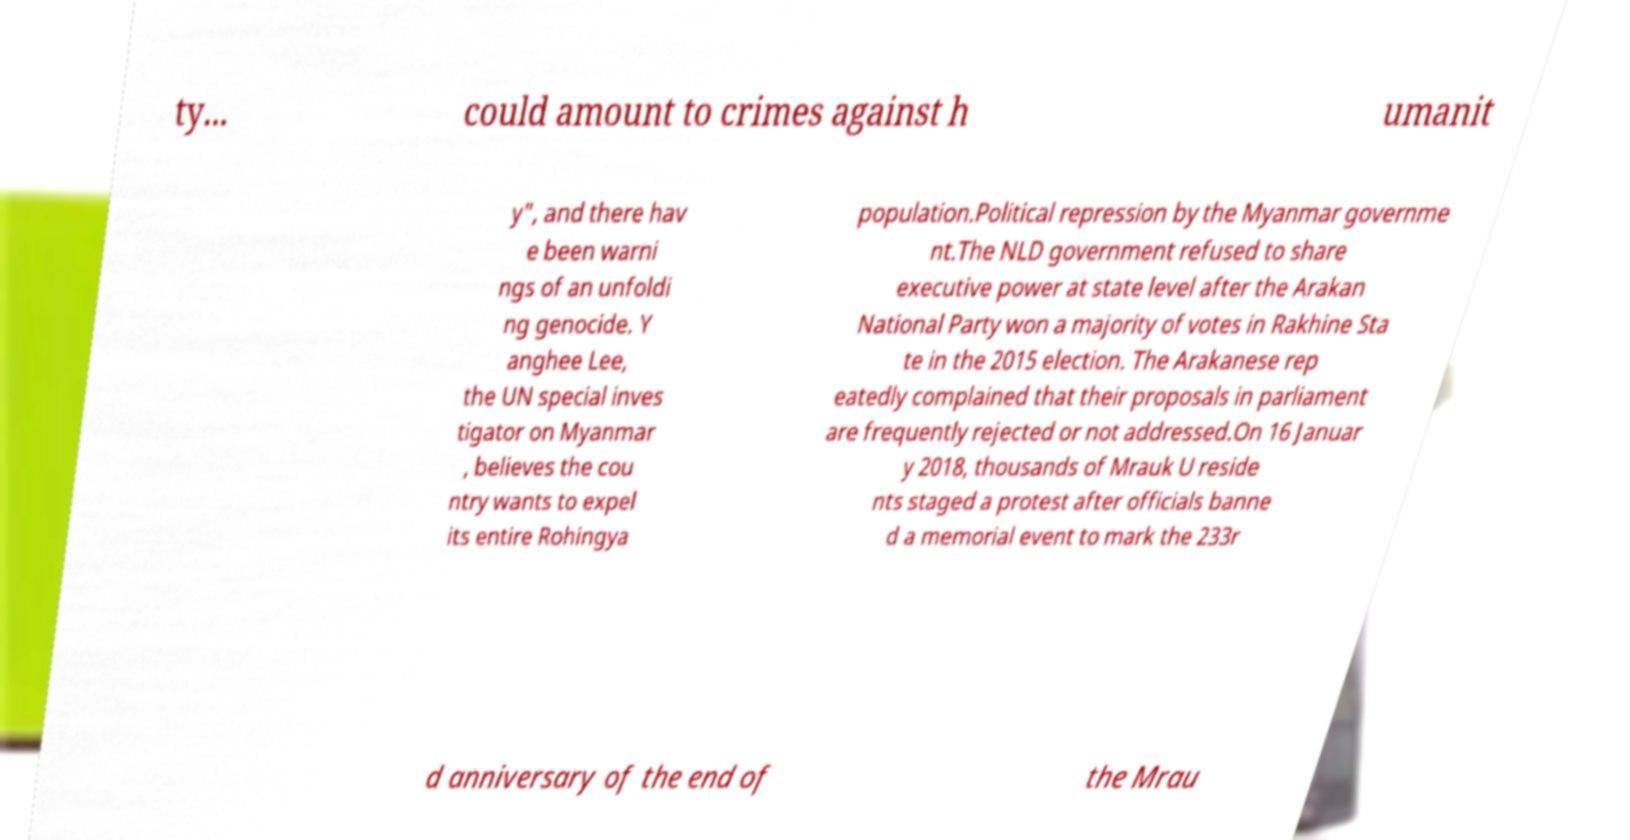Please read and relay the text visible in this image. What does it say? ty... could amount to crimes against h umanit y", and there hav e been warni ngs of an unfoldi ng genocide. Y anghee Lee, the UN special inves tigator on Myanmar , believes the cou ntry wants to expel its entire Rohingya population.Political repression by the Myanmar governme nt.The NLD government refused to share executive power at state level after the Arakan National Party won a majority of votes in Rakhine Sta te in the 2015 election. The Arakanese rep eatedly complained that their proposals in parliament are frequently rejected or not addressed.On 16 Januar y 2018, thousands of Mrauk U reside nts staged a protest after officials banne d a memorial event to mark the 233r d anniversary of the end of the Mrau 